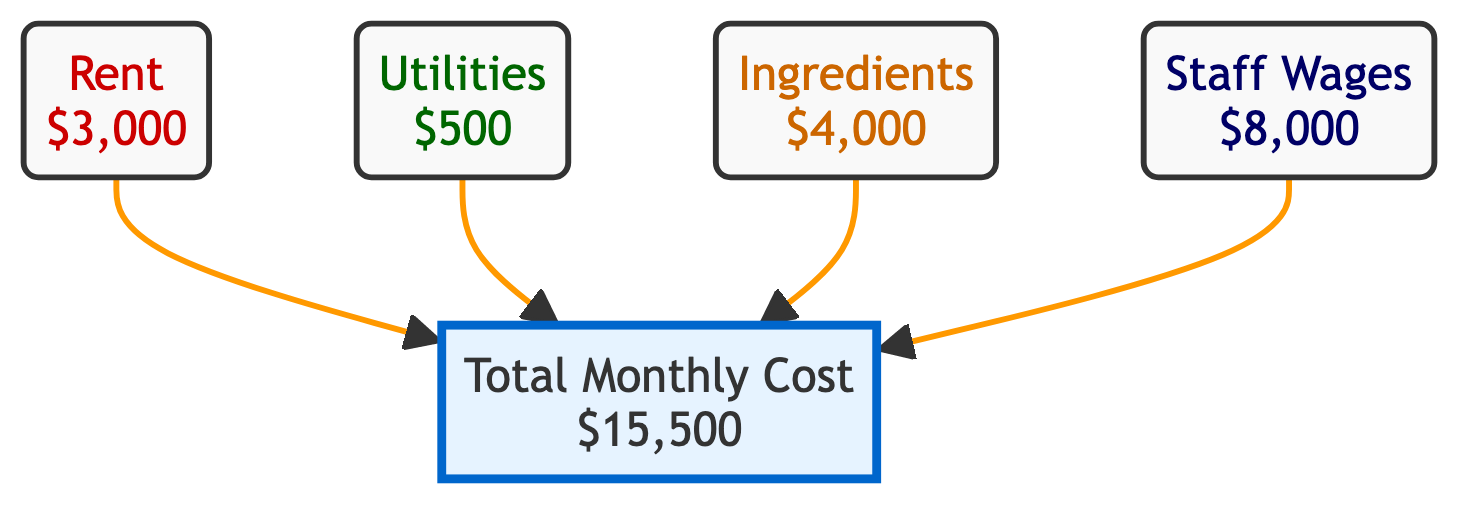What is the total monthly cost of the ramen shop? The total monthly cost is explicitly labeled in the diagram as "$15,500".
Answer: $15,500 How much do ingredients cost per month? The cost of ingredients is shown in the diagram as "$4,000".
Answer: $4,000 What is the monthly rent for the shop? The diagram indicates that the rent is "$3,000".
Answer: $3,000 How many distinct cost categories are illustrated in the diagram? There are four distinct cost categories listed: rent, utilities, ingredients, and staff wages.
Answer: 4 Which cost has the highest value in the diagram? By comparing the values, staff wages at "$8,000" is the highest.
Answer: Staff Wages What is the relationship between utilities and total cost? The diagram shows a direct connection from the utilities node to the total cost node, indicating that utilities are included in the total cost calculation.
Answer: Included How much do staff wages account for in the total monthly cost percentage-wise? To find this, calculate (staff wages / total cost) * 100 = (8,000 / 15,500) * 100, which equals approximately 51.61%.
Answer: Approximately 51.61% What style is used to represent rent in the diagram? The rent node is styled with a light red background and red text, indicating a specific style to distinguish it from other costs.
Answer: Light red, red text Which category contributes the least to the total monthly cost? By evaluating the values, utilities at "$500" contribute the least amount to the total monthly cost.
Answer: Utilities 